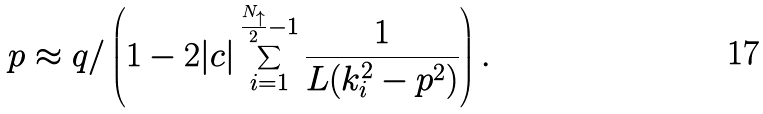<formula> <loc_0><loc_0><loc_500><loc_500>p \approx q / \left ( 1 - 2 | c | \sum _ { i = 1 } ^ { \frac { N _ { \uparrow } } { 2 } - 1 } \frac { 1 } { L ( k _ { i } ^ { 2 } - p ^ { 2 } ) } \right ) .</formula> 